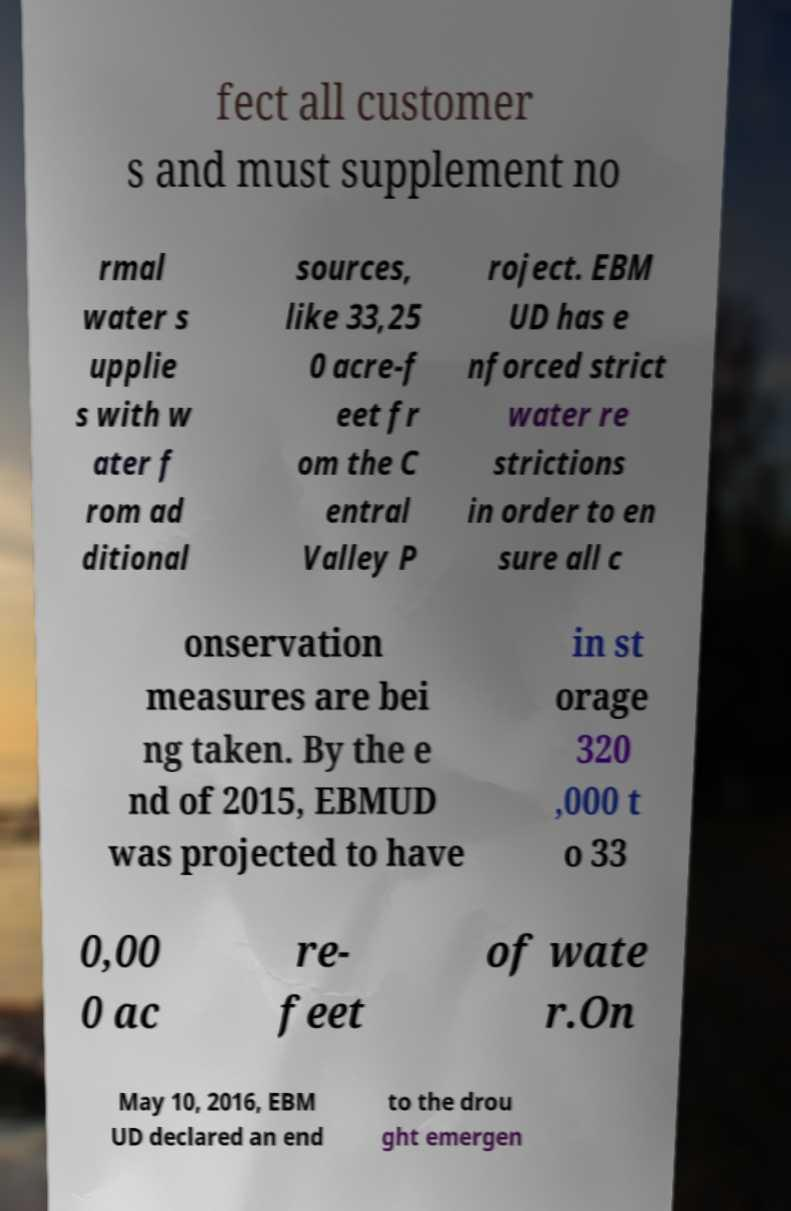Could you assist in decoding the text presented in this image and type it out clearly? fect all customer s and must supplement no rmal water s upplie s with w ater f rom ad ditional sources, like 33,25 0 acre-f eet fr om the C entral Valley P roject. EBM UD has e nforced strict water re strictions in order to en sure all c onservation measures are bei ng taken. By the e nd of 2015, EBMUD was projected to have in st orage 320 ,000 t o 33 0,00 0 ac re- feet of wate r.On May 10, 2016, EBM UD declared an end to the drou ght emergen 